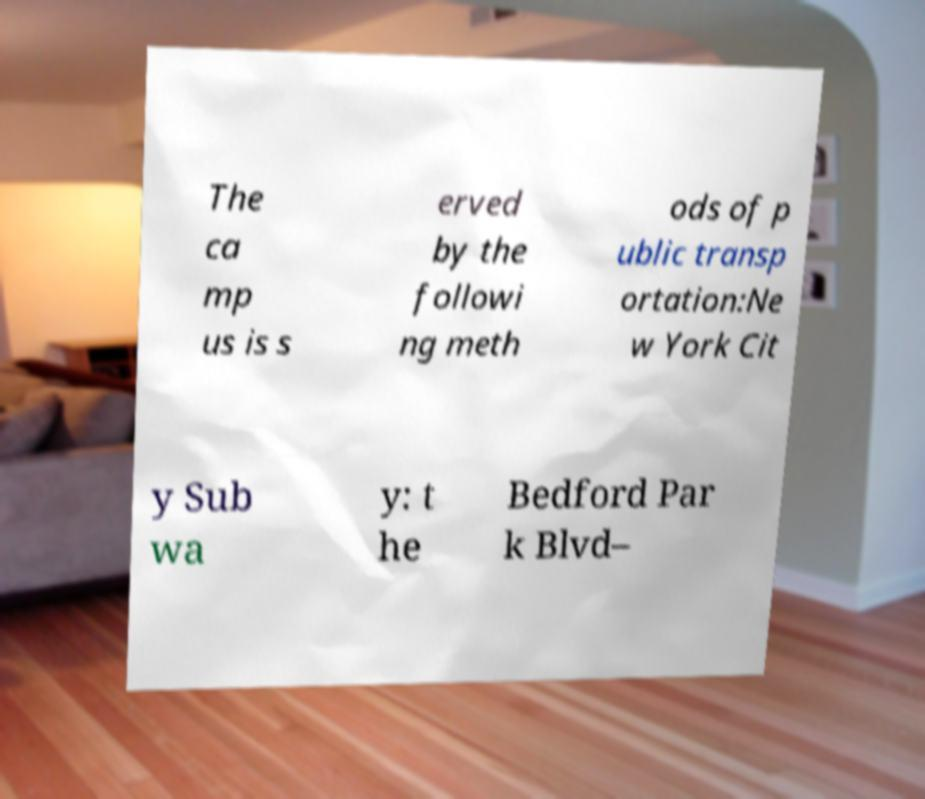There's text embedded in this image that I need extracted. Can you transcribe it verbatim? The ca mp us is s erved by the followi ng meth ods of p ublic transp ortation:Ne w York Cit y Sub wa y: t he Bedford Par k Blvd– 